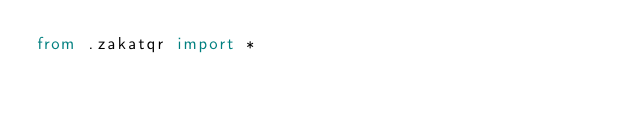<code> <loc_0><loc_0><loc_500><loc_500><_Python_>from .zakatqr import *
</code> 